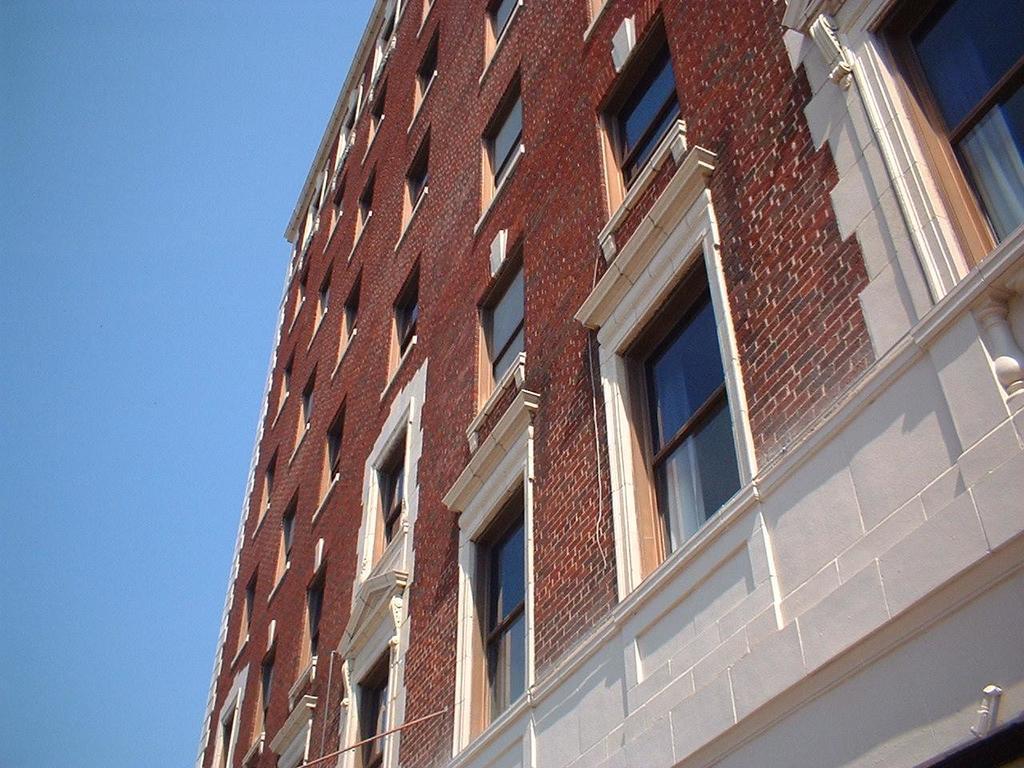Describe this image in one or two sentences. In the picture I can see the building and glass windows. I can see the brick walls. There are clouds in the sky. 